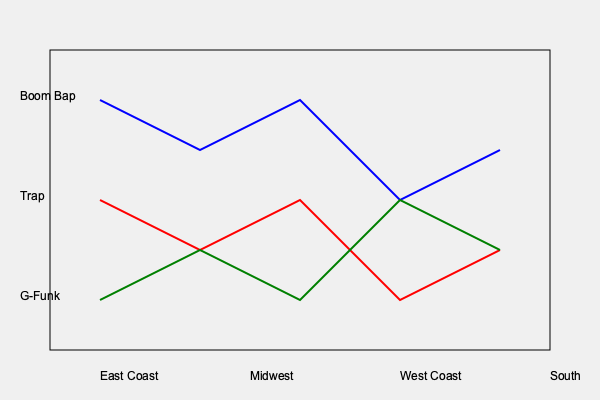Analyzing the color-coded map of hip-hop subgenres across different regions of the United States, which subgenre shows the highest prevalence in the South, and how does this reflect the evolution of mainstream rap in recent years? To answer this question, we need to analyze the graph and interpret its representation of hip-hop subgenres across different regions:

1. The graph shows three lines representing different hip-hop subgenres:
   - Blue line: Boom Bap
   - Red line: Trap
   - Green line: G-Funk

2. The x-axis represents different regions: East Coast, Midwest, West Coast, and South.

3. The y-axis represents the prevalence or popularity of each subgenre in each region.

4. Focusing on the South region (rightmost part of the graph):
   - The red line (Trap) is highest in this region.
   - The blue line (Boom Bap) and green line (G-Funk) are lower.

5. This indicates that Trap is the most prevalent subgenre in the South.

6. Reflecting on the evolution of mainstream rap:
   - Trap originated in the South (particularly Atlanta) in the late 1990s and early 2000s.
   - Over the past decade, Trap has become increasingly dominant in mainstream rap.
   - The graph reflects this trend, showing Trap's strong presence in the South and its influence across other regions.

7. The prevalence of Trap in the South and its spread to other regions demonstrates how regional sounds can evolve into mainstream trends, influencing the overall landscape of hip-hop.

This analysis shows that Trap, originating from the South, has become a significant force in shaping contemporary mainstream rap, reflecting the genre's ability to evolve and incorporate regional influences into the broader hip-hop culture.
Answer: Trap; reflects Southern influence on mainstream rap evolution 